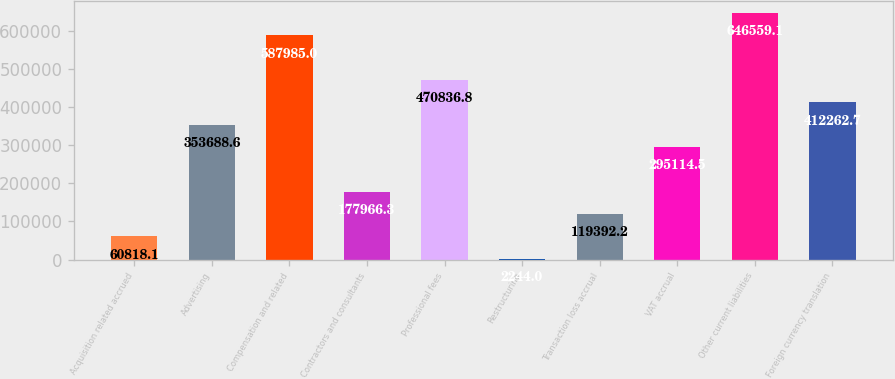Convert chart. <chart><loc_0><loc_0><loc_500><loc_500><bar_chart><fcel>Acquisition related accrued<fcel>Advertising<fcel>Compensation and related<fcel>Contractors and consultants<fcel>Professional fees<fcel>Restructuring<fcel>Transaction loss accrual<fcel>VAT accrual<fcel>Other current liabilities<fcel>Foreign currency translation<nl><fcel>60818.1<fcel>353689<fcel>587985<fcel>177966<fcel>470837<fcel>2244<fcel>119392<fcel>295114<fcel>646559<fcel>412263<nl></chart> 